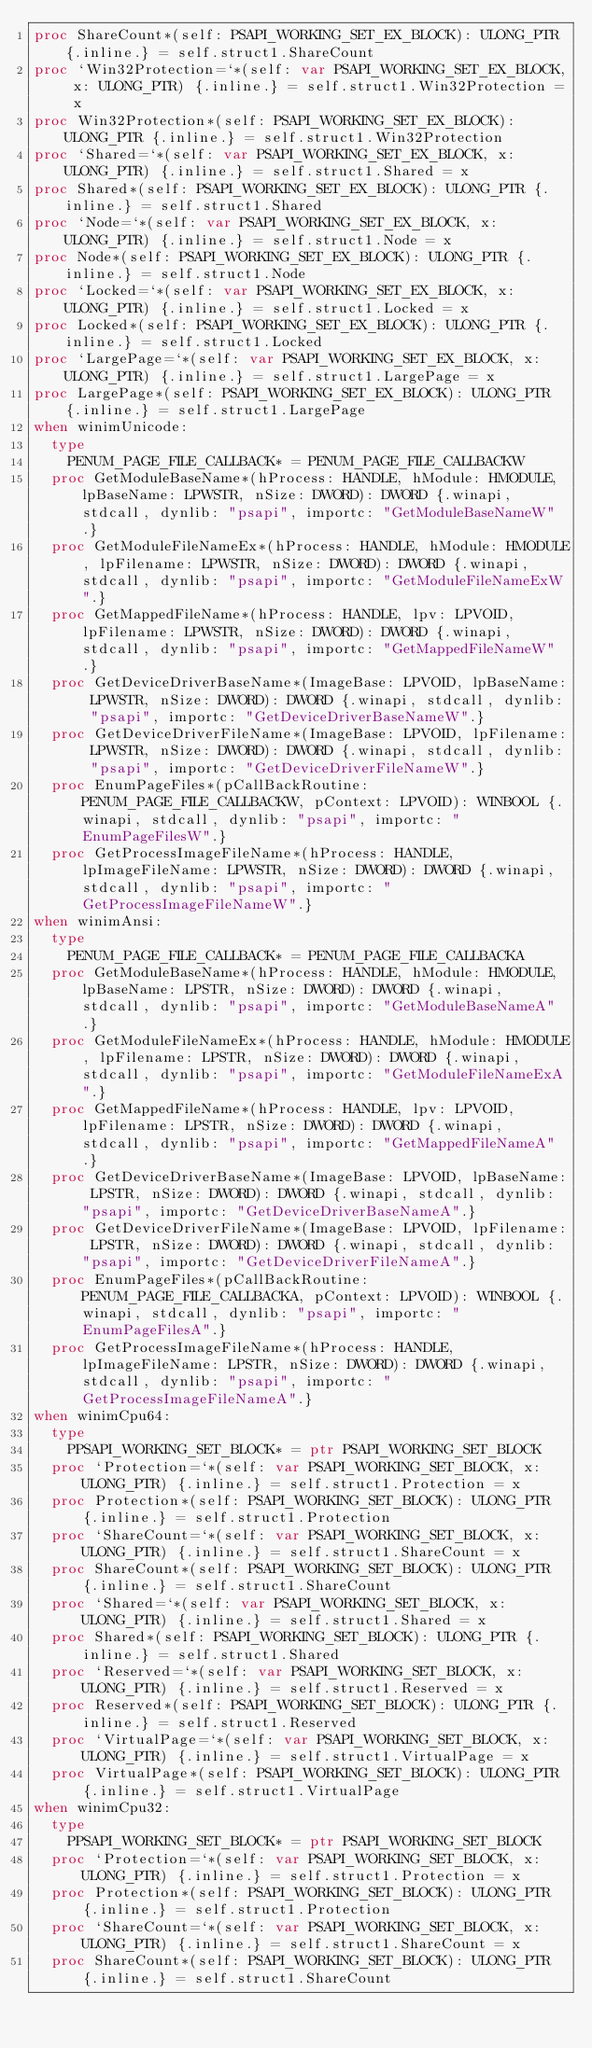Convert code to text. <code><loc_0><loc_0><loc_500><loc_500><_Nim_>proc ShareCount*(self: PSAPI_WORKING_SET_EX_BLOCK): ULONG_PTR {.inline.} = self.struct1.ShareCount
proc `Win32Protection=`*(self: var PSAPI_WORKING_SET_EX_BLOCK, x: ULONG_PTR) {.inline.} = self.struct1.Win32Protection = x
proc Win32Protection*(self: PSAPI_WORKING_SET_EX_BLOCK): ULONG_PTR {.inline.} = self.struct1.Win32Protection
proc `Shared=`*(self: var PSAPI_WORKING_SET_EX_BLOCK, x: ULONG_PTR) {.inline.} = self.struct1.Shared = x
proc Shared*(self: PSAPI_WORKING_SET_EX_BLOCK): ULONG_PTR {.inline.} = self.struct1.Shared
proc `Node=`*(self: var PSAPI_WORKING_SET_EX_BLOCK, x: ULONG_PTR) {.inline.} = self.struct1.Node = x
proc Node*(self: PSAPI_WORKING_SET_EX_BLOCK): ULONG_PTR {.inline.} = self.struct1.Node
proc `Locked=`*(self: var PSAPI_WORKING_SET_EX_BLOCK, x: ULONG_PTR) {.inline.} = self.struct1.Locked = x
proc Locked*(self: PSAPI_WORKING_SET_EX_BLOCK): ULONG_PTR {.inline.} = self.struct1.Locked
proc `LargePage=`*(self: var PSAPI_WORKING_SET_EX_BLOCK, x: ULONG_PTR) {.inline.} = self.struct1.LargePage = x
proc LargePage*(self: PSAPI_WORKING_SET_EX_BLOCK): ULONG_PTR {.inline.} = self.struct1.LargePage
when winimUnicode:
  type
    PENUM_PAGE_FILE_CALLBACK* = PENUM_PAGE_FILE_CALLBACKW
  proc GetModuleBaseName*(hProcess: HANDLE, hModule: HMODULE, lpBaseName: LPWSTR, nSize: DWORD): DWORD {.winapi, stdcall, dynlib: "psapi", importc: "GetModuleBaseNameW".}
  proc GetModuleFileNameEx*(hProcess: HANDLE, hModule: HMODULE, lpFilename: LPWSTR, nSize: DWORD): DWORD {.winapi, stdcall, dynlib: "psapi", importc: "GetModuleFileNameExW".}
  proc GetMappedFileName*(hProcess: HANDLE, lpv: LPVOID, lpFilename: LPWSTR, nSize: DWORD): DWORD {.winapi, stdcall, dynlib: "psapi", importc: "GetMappedFileNameW".}
  proc GetDeviceDriverBaseName*(ImageBase: LPVOID, lpBaseName: LPWSTR, nSize: DWORD): DWORD {.winapi, stdcall, dynlib: "psapi", importc: "GetDeviceDriverBaseNameW".}
  proc GetDeviceDriverFileName*(ImageBase: LPVOID, lpFilename: LPWSTR, nSize: DWORD): DWORD {.winapi, stdcall, dynlib: "psapi", importc: "GetDeviceDriverFileNameW".}
  proc EnumPageFiles*(pCallBackRoutine: PENUM_PAGE_FILE_CALLBACKW, pContext: LPVOID): WINBOOL {.winapi, stdcall, dynlib: "psapi", importc: "EnumPageFilesW".}
  proc GetProcessImageFileName*(hProcess: HANDLE, lpImageFileName: LPWSTR, nSize: DWORD): DWORD {.winapi, stdcall, dynlib: "psapi", importc: "GetProcessImageFileNameW".}
when winimAnsi:
  type
    PENUM_PAGE_FILE_CALLBACK* = PENUM_PAGE_FILE_CALLBACKA
  proc GetModuleBaseName*(hProcess: HANDLE, hModule: HMODULE, lpBaseName: LPSTR, nSize: DWORD): DWORD {.winapi, stdcall, dynlib: "psapi", importc: "GetModuleBaseNameA".}
  proc GetModuleFileNameEx*(hProcess: HANDLE, hModule: HMODULE, lpFilename: LPSTR, nSize: DWORD): DWORD {.winapi, stdcall, dynlib: "psapi", importc: "GetModuleFileNameExA".}
  proc GetMappedFileName*(hProcess: HANDLE, lpv: LPVOID, lpFilename: LPSTR, nSize: DWORD): DWORD {.winapi, stdcall, dynlib: "psapi", importc: "GetMappedFileNameA".}
  proc GetDeviceDriverBaseName*(ImageBase: LPVOID, lpBaseName: LPSTR, nSize: DWORD): DWORD {.winapi, stdcall, dynlib: "psapi", importc: "GetDeviceDriverBaseNameA".}
  proc GetDeviceDriverFileName*(ImageBase: LPVOID, lpFilename: LPSTR, nSize: DWORD): DWORD {.winapi, stdcall, dynlib: "psapi", importc: "GetDeviceDriverFileNameA".}
  proc EnumPageFiles*(pCallBackRoutine: PENUM_PAGE_FILE_CALLBACKA, pContext: LPVOID): WINBOOL {.winapi, stdcall, dynlib: "psapi", importc: "EnumPageFilesA".}
  proc GetProcessImageFileName*(hProcess: HANDLE, lpImageFileName: LPSTR, nSize: DWORD): DWORD {.winapi, stdcall, dynlib: "psapi", importc: "GetProcessImageFileNameA".}
when winimCpu64:
  type
    PPSAPI_WORKING_SET_BLOCK* = ptr PSAPI_WORKING_SET_BLOCK
  proc `Protection=`*(self: var PSAPI_WORKING_SET_BLOCK, x: ULONG_PTR) {.inline.} = self.struct1.Protection = x
  proc Protection*(self: PSAPI_WORKING_SET_BLOCK): ULONG_PTR {.inline.} = self.struct1.Protection
  proc `ShareCount=`*(self: var PSAPI_WORKING_SET_BLOCK, x: ULONG_PTR) {.inline.} = self.struct1.ShareCount = x
  proc ShareCount*(self: PSAPI_WORKING_SET_BLOCK): ULONG_PTR {.inline.} = self.struct1.ShareCount
  proc `Shared=`*(self: var PSAPI_WORKING_SET_BLOCK, x: ULONG_PTR) {.inline.} = self.struct1.Shared = x
  proc Shared*(self: PSAPI_WORKING_SET_BLOCK): ULONG_PTR {.inline.} = self.struct1.Shared
  proc `Reserved=`*(self: var PSAPI_WORKING_SET_BLOCK, x: ULONG_PTR) {.inline.} = self.struct1.Reserved = x
  proc Reserved*(self: PSAPI_WORKING_SET_BLOCK): ULONG_PTR {.inline.} = self.struct1.Reserved
  proc `VirtualPage=`*(self: var PSAPI_WORKING_SET_BLOCK, x: ULONG_PTR) {.inline.} = self.struct1.VirtualPage = x
  proc VirtualPage*(self: PSAPI_WORKING_SET_BLOCK): ULONG_PTR {.inline.} = self.struct1.VirtualPage
when winimCpu32:
  type
    PPSAPI_WORKING_SET_BLOCK* = ptr PSAPI_WORKING_SET_BLOCK
  proc `Protection=`*(self: var PSAPI_WORKING_SET_BLOCK, x: ULONG_PTR) {.inline.} = self.struct1.Protection = x
  proc Protection*(self: PSAPI_WORKING_SET_BLOCK): ULONG_PTR {.inline.} = self.struct1.Protection
  proc `ShareCount=`*(self: var PSAPI_WORKING_SET_BLOCK, x: ULONG_PTR) {.inline.} = self.struct1.ShareCount = x
  proc ShareCount*(self: PSAPI_WORKING_SET_BLOCK): ULONG_PTR {.inline.} = self.struct1.ShareCount</code> 